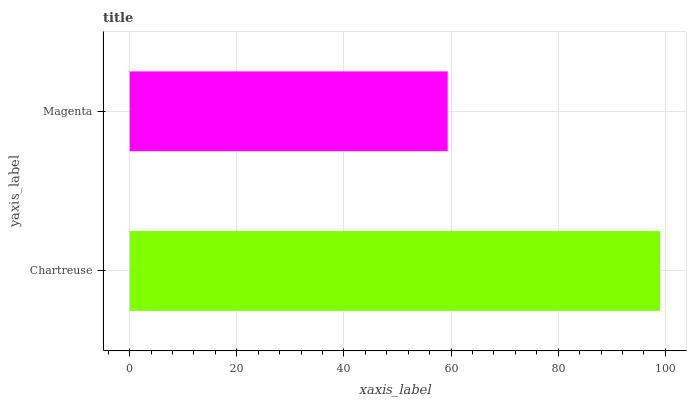Is Magenta the minimum?
Answer yes or no. Yes. Is Chartreuse the maximum?
Answer yes or no. Yes. Is Magenta the maximum?
Answer yes or no. No. Is Chartreuse greater than Magenta?
Answer yes or no. Yes. Is Magenta less than Chartreuse?
Answer yes or no. Yes. Is Magenta greater than Chartreuse?
Answer yes or no. No. Is Chartreuse less than Magenta?
Answer yes or no. No. Is Chartreuse the high median?
Answer yes or no. Yes. Is Magenta the low median?
Answer yes or no. Yes. Is Magenta the high median?
Answer yes or no. No. Is Chartreuse the low median?
Answer yes or no. No. 